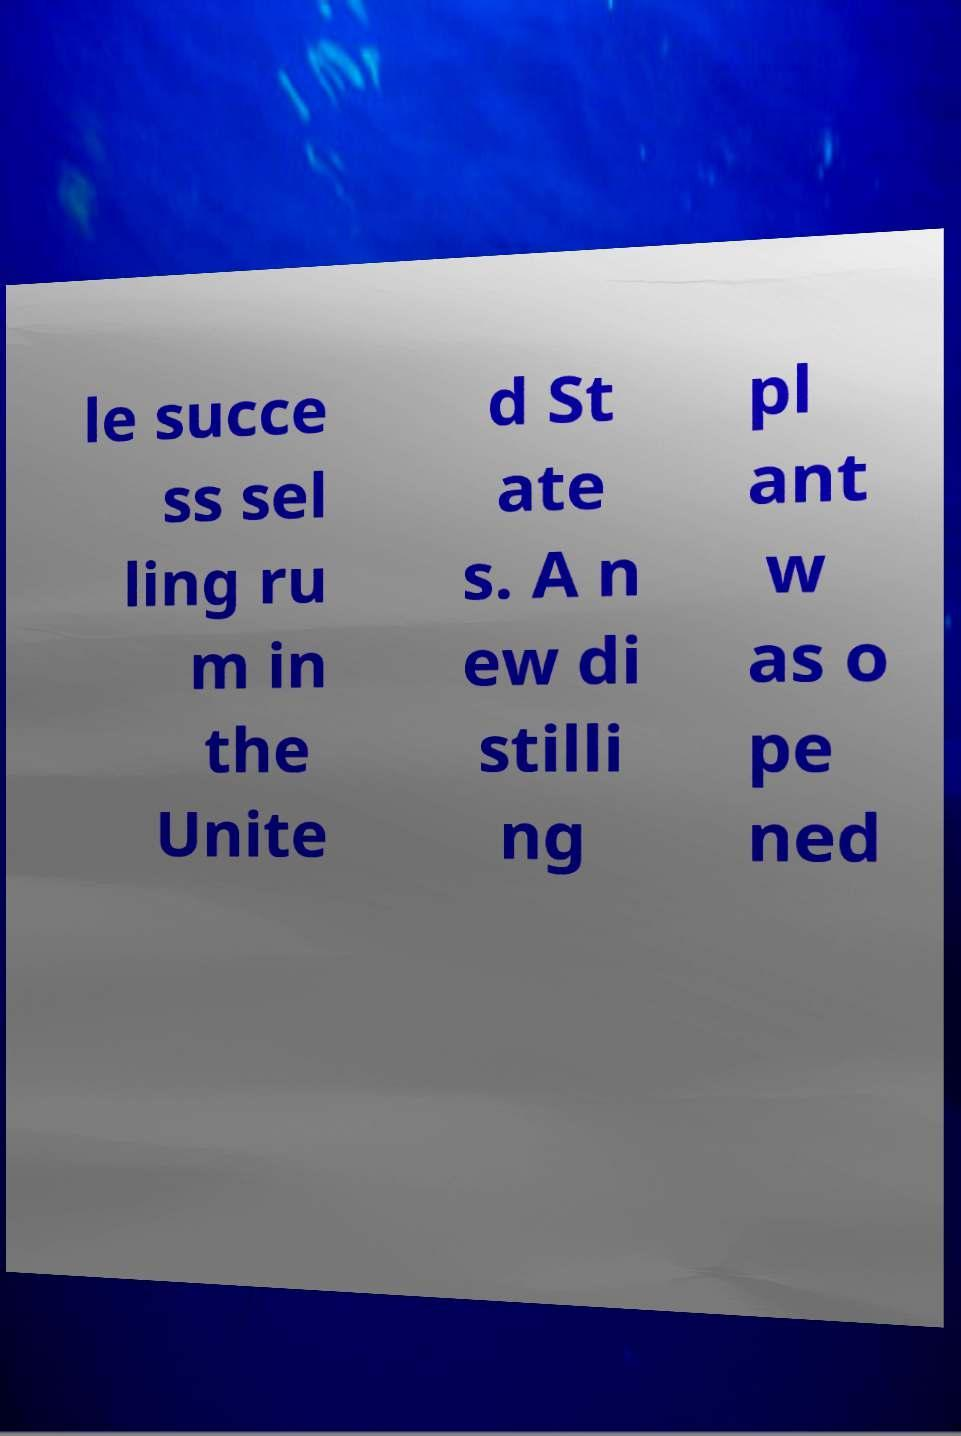Can you read and provide the text displayed in the image?This photo seems to have some interesting text. Can you extract and type it out for me? le succe ss sel ling ru m in the Unite d St ate s. A n ew di stilli ng pl ant w as o pe ned 